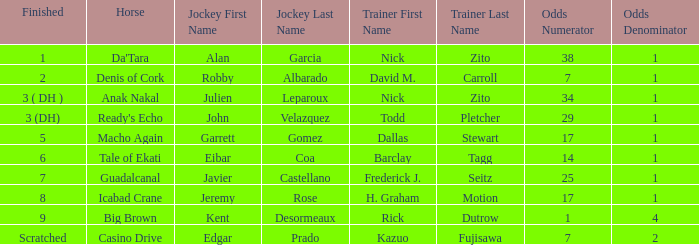Which horse ended up in the 8th position? Icabad Crane. 